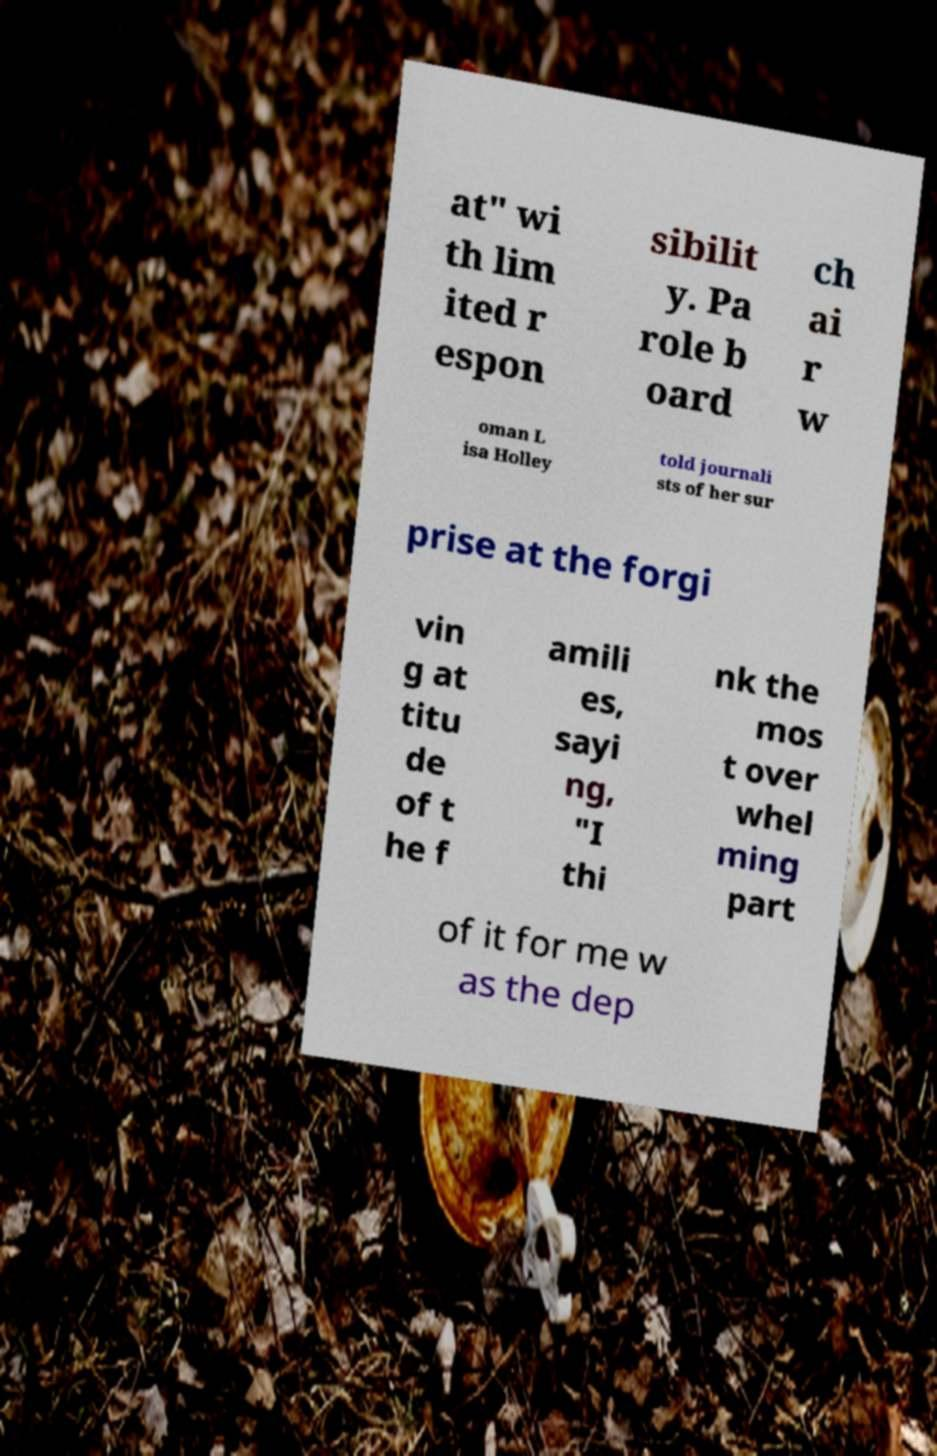There's text embedded in this image that I need extracted. Can you transcribe it verbatim? at" wi th lim ited r espon sibilit y. Pa role b oard ch ai r w oman L isa Holley told journali sts of her sur prise at the forgi vin g at titu de of t he f amili es, sayi ng, "I thi nk the mos t over whel ming part of it for me w as the dep 